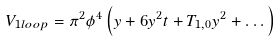<formula> <loc_0><loc_0><loc_500><loc_500>V _ { 1 l o o p } = \pi ^ { 2 } \phi ^ { 4 } \left ( y + 6 y ^ { 2 } t + T _ { 1 , 0 } y ^ { 2 } + \dots \right )</formula> 